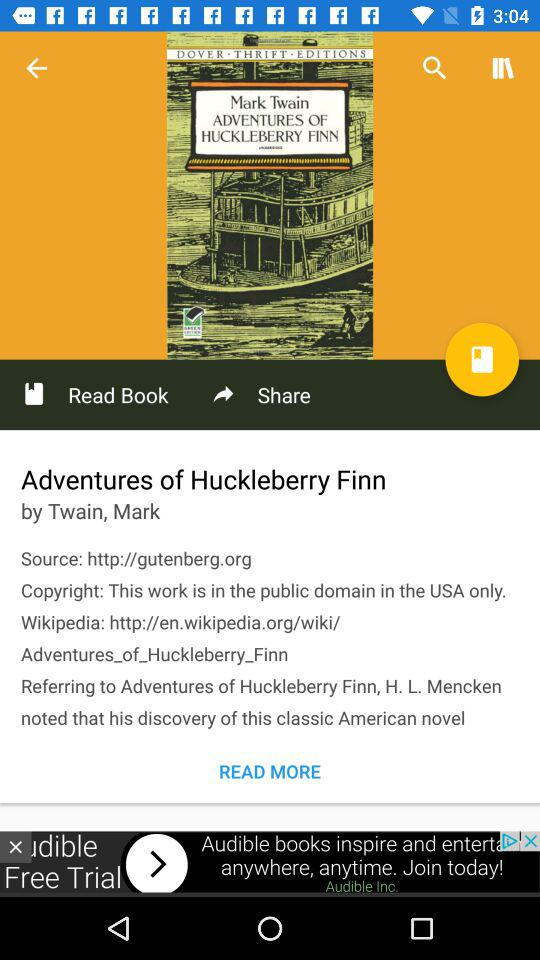What is the source of the article? The source of the article is http://gutenberg.org. 